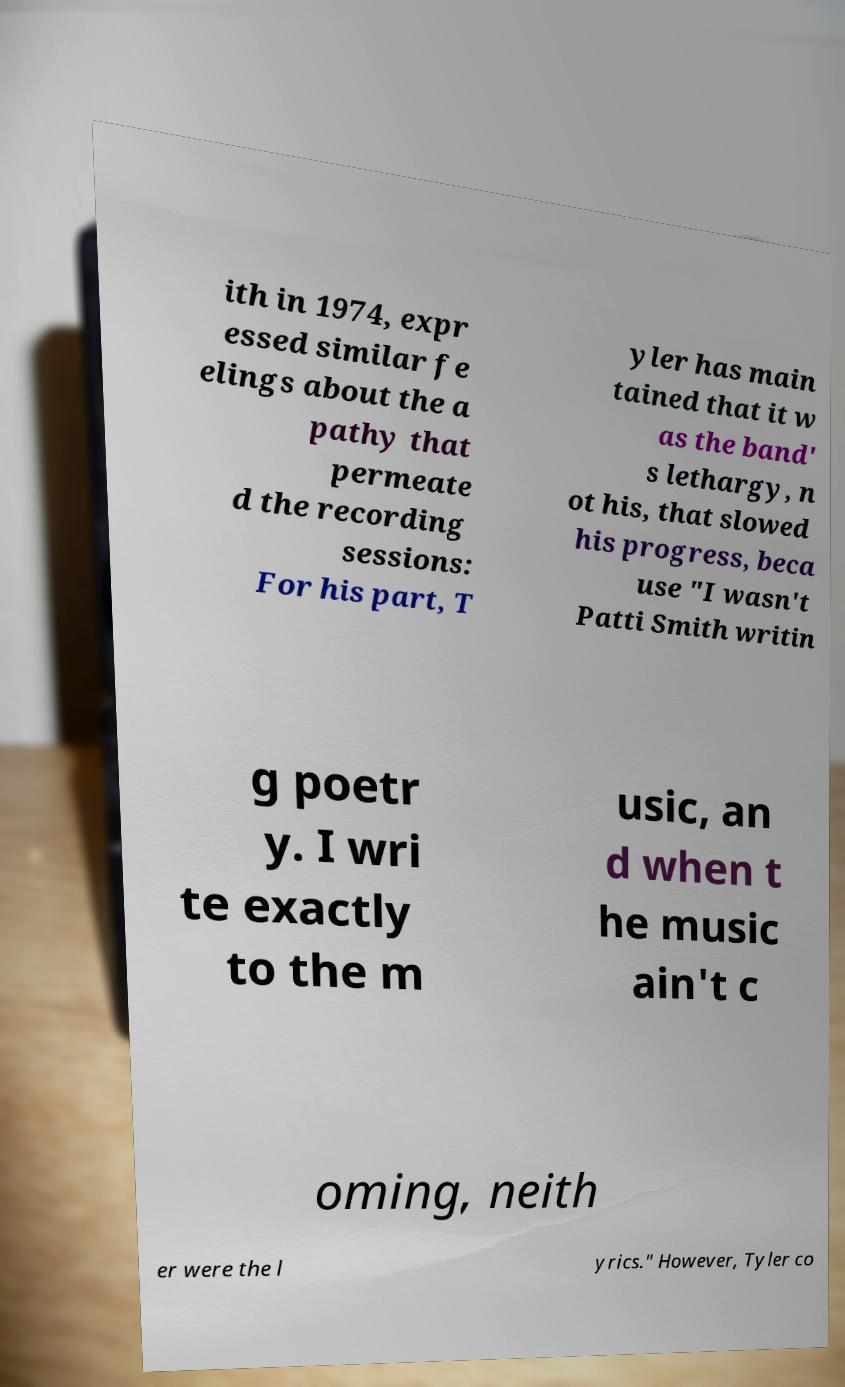Please identify and transcribe the text found in this image. ith in 1974, expr essed similar fe elings about the a pathy that permeate d the recording sessions: For his part, T yler has main tained that it w as the band' s lethargy, n ot his, that slowed his progress, beca use "I wasn't Patti Smith writin g poetr y. I wri te exactly to the m usic, an d when t he music ain't c oming, neith er were the l yrics." However, Tyler co 